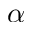<formula> <loc_0><loc_0><loc_500><loc_500>\alpha</formula> 